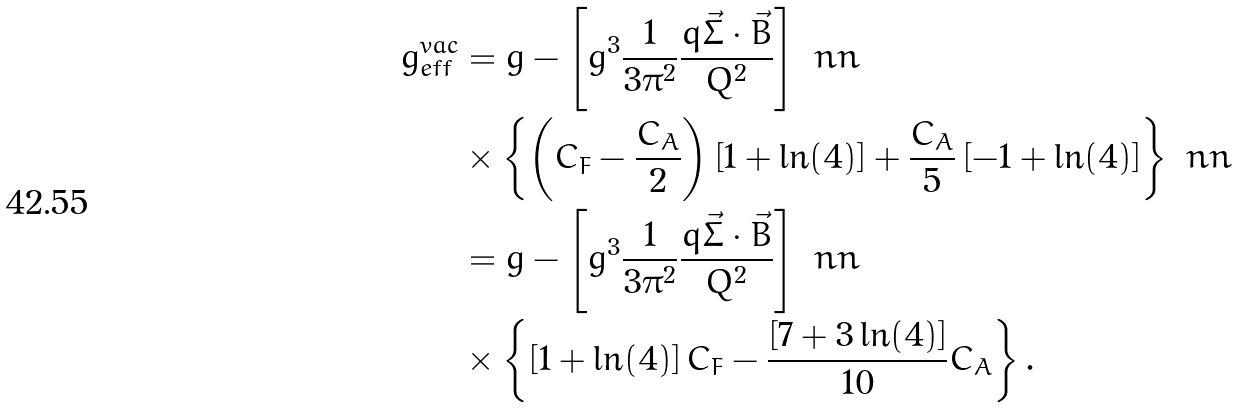<formula> <loc_0><loc_0><loc_500><loc_500>g _ { e f f } ^ { v a c } & = g - \left [ g ^ { 3 } \frac { 1 } { 3 \pi ^ { 2 } } \frac { q \vec { \Sigma } \cdot \vec { B } } { Q ^ { 2 } } \right ] \ n n \\ & \times \left \{ \left ( C _ { F } - \frac { C _ { A } } { 2 } \right ) \left [ 1 + \ln ( 4 ) \right ] + \frac { C _ { A } } { 5 } \left [ - 1 + \ln ( 4 ) \right ] \right \} \ n n \\ & = g - \left [ g ^ { 3 } \frac { 1 } { 3 \pi ^ { 2 } } \frac { q \vec { \Sigma } \cdot \vec { B } } { Q ^ { 2 } } \right ] \ n n \\ & \times \left \{ \left [ 1 + \ln ( 4 ) \right ] C _ { F } - \frac { \left [ 7 + 3 \ln ( 4 ) \right ] } { 1 0 } C _ { A } \right \} .</formula> 